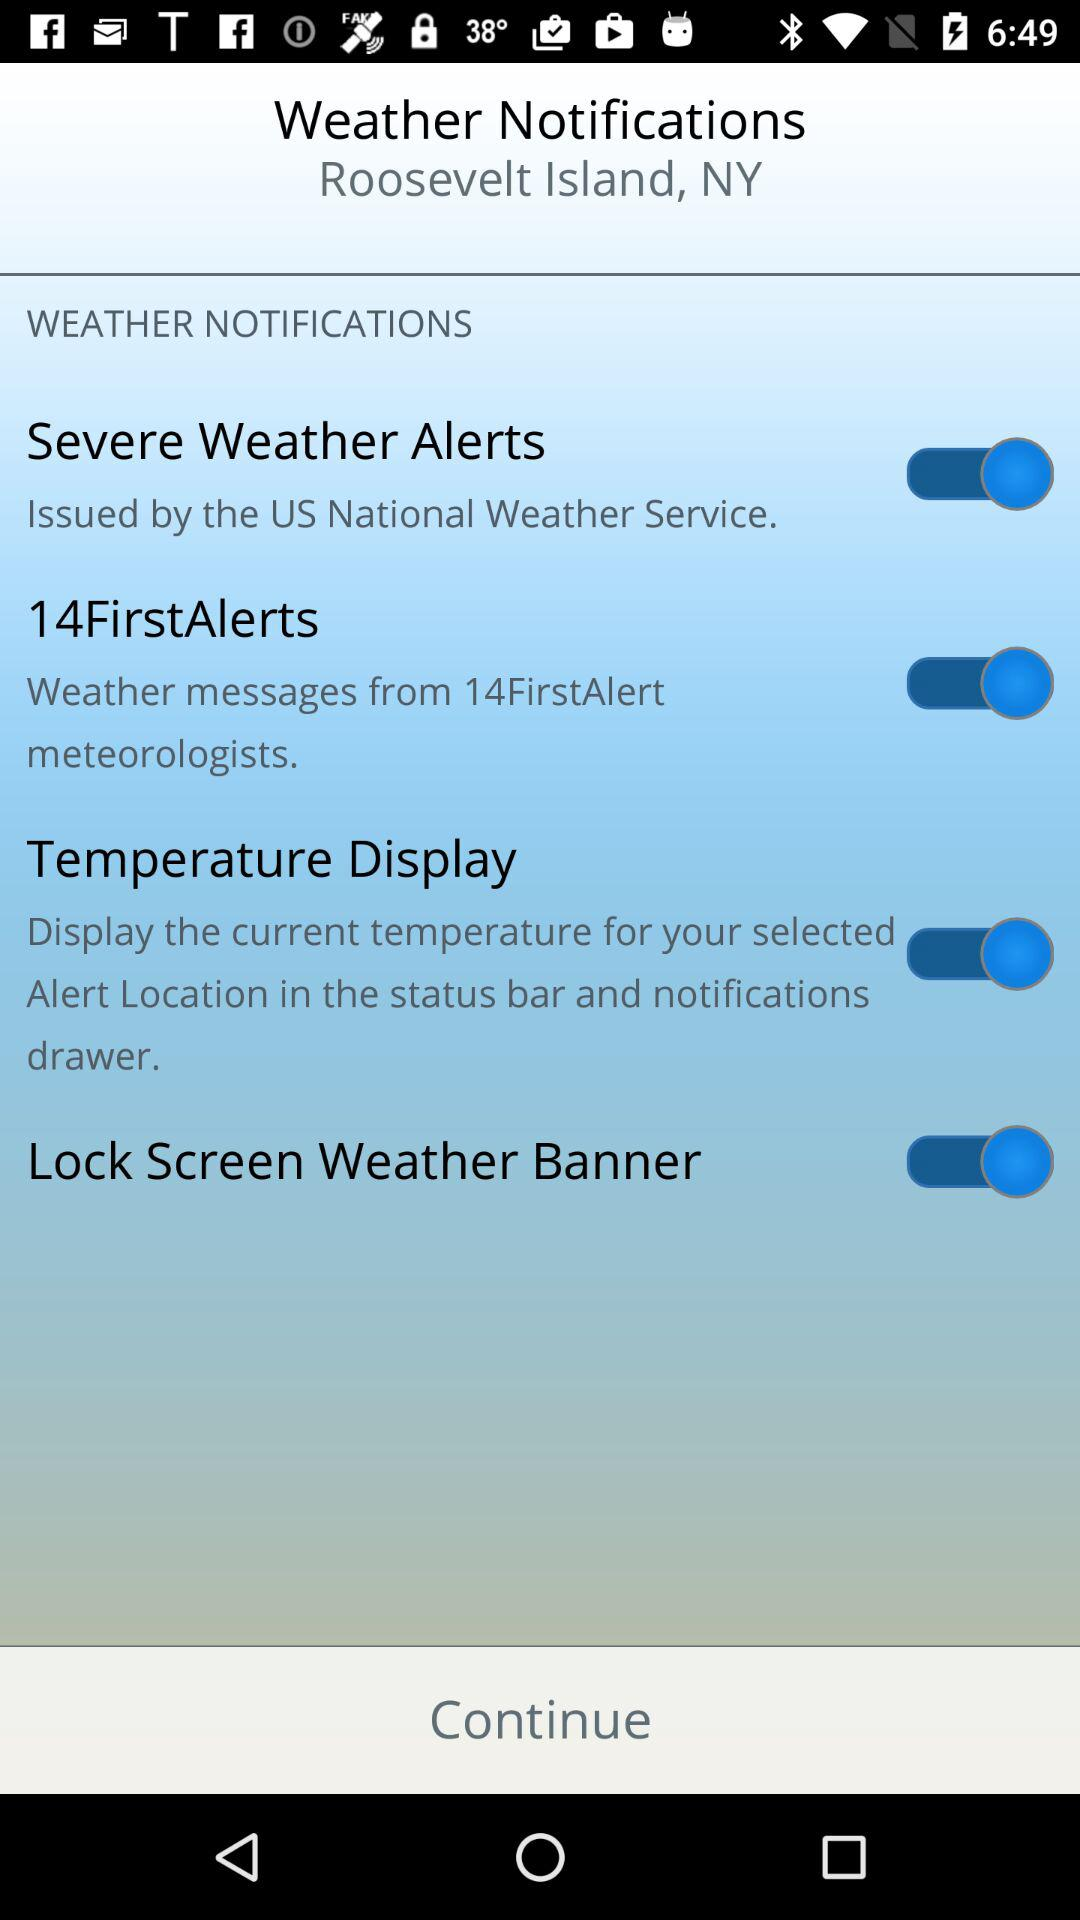What is the status of the "Temperature Display"? The status is "on". 